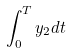Convert formula to latex. <formula><loc_0><loc_0><loc_500><loc_500>\int _ { 0 } ^ { T } y _ { 2 } d t</formula> 